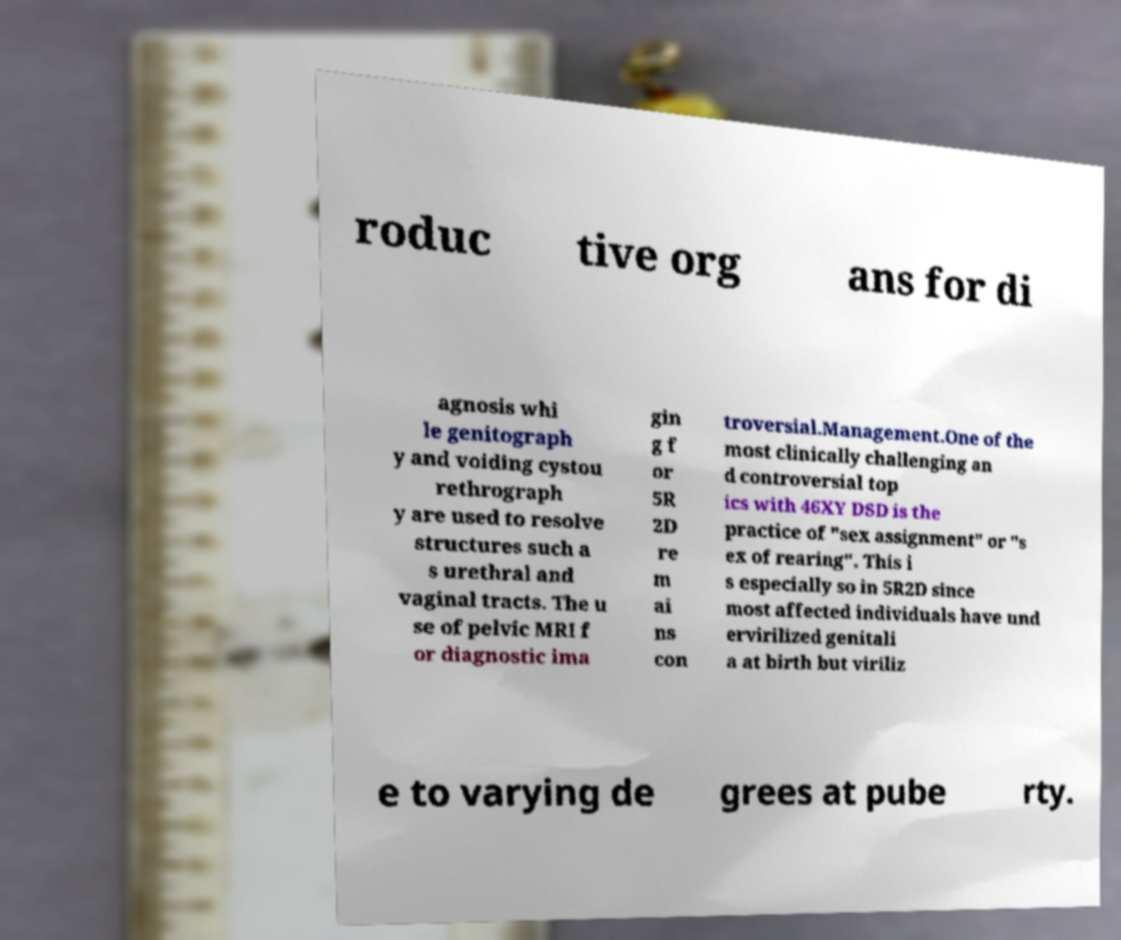There's text embedded in this image that I need extracted. Can you transcribe it verbatim? roduc tive org ans for di agnosis whi le genitograph y and voiding cystou rethrograph y are used to resolve structures such a s urethral and vaginal tracts. The u se of pelvic MRI f or diagnostic ima gin g f or 5R 2D re m ai ns con troversial.Management.One of the most clinically challenging an d controversial top ics with 46XY DSD is the practice of "sex assignment" or "s ex of rearing". This i s especially so in 5R2D since most affected individuals have und ervirilized genitali a at birth but viriliz e to varying de grees at pube rty. 